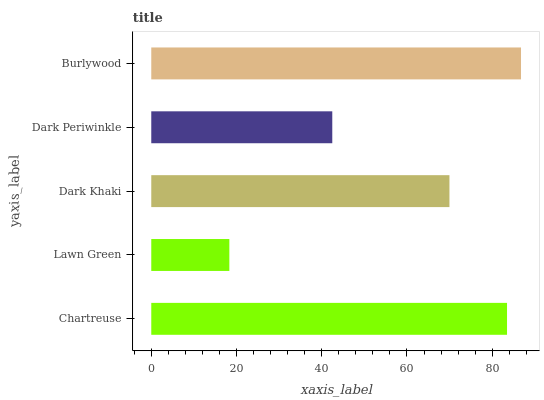Is Lawn Green the minimum?
Answer yes or no. Yes. Is Burlywood the maximum?
Answer yes or no. Yes. Is Dark Khaki the minimum?
Answer yes or no. No. Is Dark Khaki the maximum?
Answer yes or no. No. Is Dark Khaki greater than Lawn Green?
Answer yes or no. Yes. Is Lawn Green less than Dark Khaki?
Answer yes or no. Yes. Is Lawn Green greater than Dark Khaki?
Answer yes or no. No. Is Dark Khaki less than Lawn Green?
Answer yes or no. No. Is Dark Khaki the high median?
Answer yes or no. Yes. Is Dark Khaki the low median?
Answer yes or no. Yes. Is Burlywood the high median?
Answer yes or no. No. Is Chartreuse the low median?
Answer yes or no. No. 